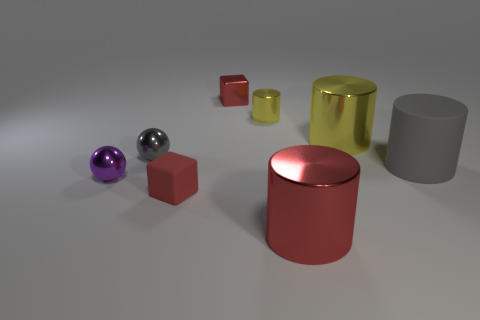Is the number of tiny yellow metallic things behind the red rubber block less than the number of tiny purple metal spheres in front of the tiny red metal object?
Offer a very short reply. No. There is a large object behind the tiny gray shiny sphere; is it the same color as the rubber thing that is on the right side of the red rubber cube?
Offer a very short reply. No. Are there any big gray cylinders that have the same material as the gray ball?
Your answer should be compact. No. How big is the cube that is in front of the tiny yellow cylinder behind the big yellow metallic object?
Ensure brevity in your answer.  Small. Are there more gray shiny spheres than cyan rubber cylinders?
Keep it short and to the point. Yes. There is a yellow cylinder to the left of the red shiny cylinder; does it have the same size as the tiny gray metal thing?
Your response must be concise. Yes. How many other cylinders are the same color as the tiny shiny cylinder?
Make the answer very short. 1. Does the small purple metallic thing have the same shape as the gray metal thing?
Offer a terse response. Yes. There is a purple object that is the same shape as the gray metal thing; what size is it?
Offer a very short reply. Small. Are there more large red shiny things that are on the right side of the red matte block than purple spheres right of the large gray matte thing?
Keep it short and to the point. Yes. 